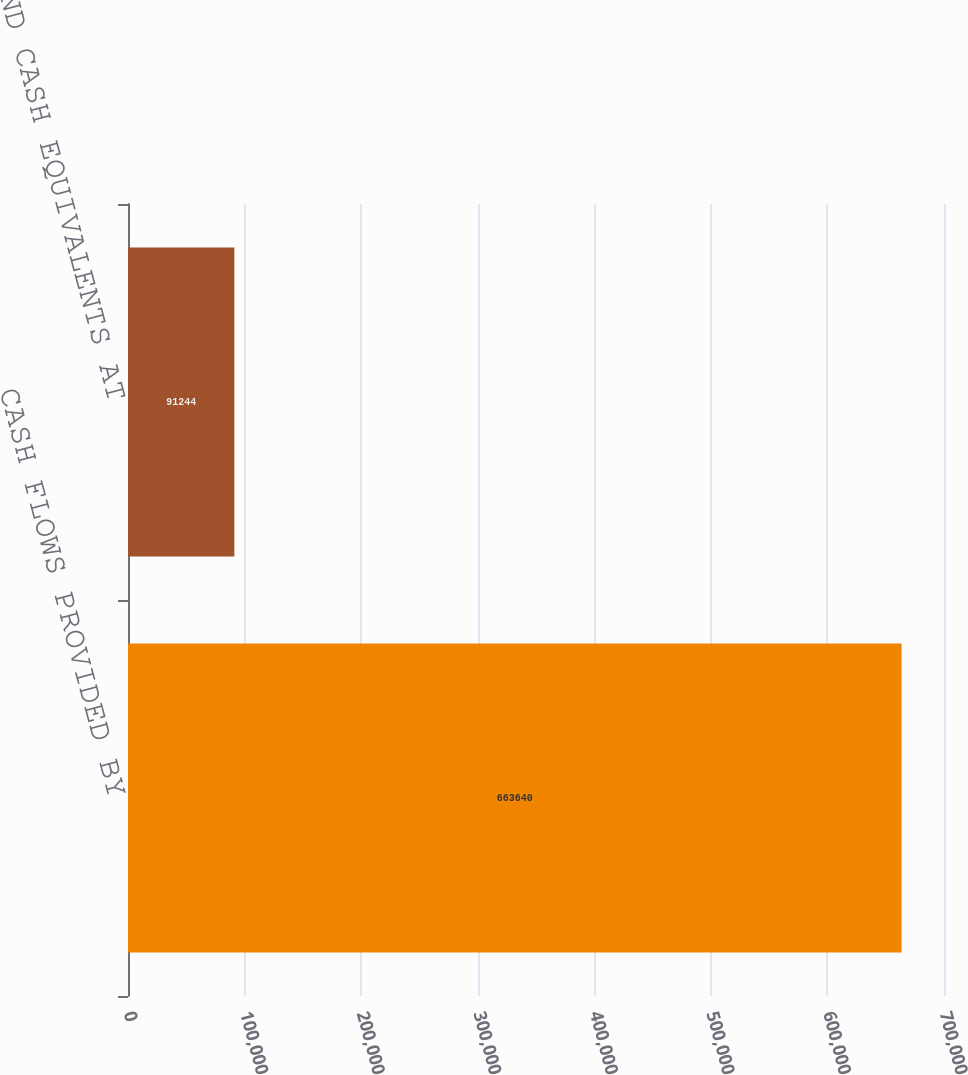<chart> <loc_0><loc_0><loc_500><loc_500><bar_chart><fcel>CASH FLOWS PROVIDED BY<fcel>CASH AND CASH EQUIVALENTS AT<nl><fcel>663640<fcel>91244<nl></chart> 